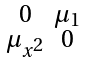<formula> <loc_0><loc_0><loc_500><loc_500>\begin{smallmatrix} 0 & \mu _ { 1 } \\ \mu _ { x ^ { 2 } } & 0 \end{smallmatrix}</formula> 